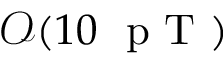Convert formula to latex. <formula><loc_0><loc_0><loc_500><loc_500>\mathcal { O } ( 1 0 p T )</formula> 